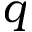<formula> <loc_0><loc_0><loc_500><loc_500>q</formula> 